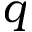<formula> <loc_0><loc_0><loc_500><loc_500>q</formula> 